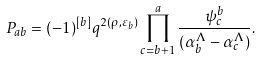Convert formula to latex. <formula><loc_0><loc_0><loc_500><loc_500>P _ { a b } = ( - 1 ) ^ { [ b ] } q ^ { 2 ( \rho , \varepsilon _ { b } ) } \prod _ { c = b + 1 } ^ { a } \frac { \psi ^ { b } _ { c } } { ( \alpha _ { b } ^ { \Lambda } - \alpha _ { c } ^ { \Lambda } ) } .</formula> 